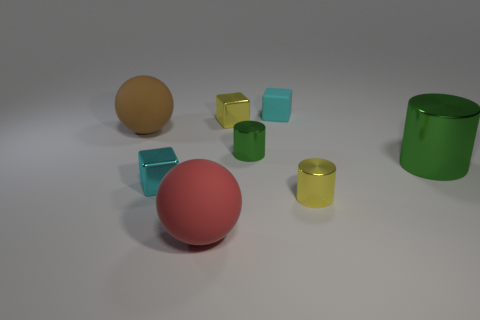Are there fewer red balls left of the tiny matte object than cyan rubber cubes that are left of the red rubber sphere? Upon inspecting the image, it appears that there are no red balls to the left of the tiny matte object. However, there are two cyan rubber cubes to the left of the red rubber sphere. Since the comparison in the original question does not hold—as there are no red balls left of the matte object—the answer to the posed question would be that it is not applicable or the comparison cannot be made. 